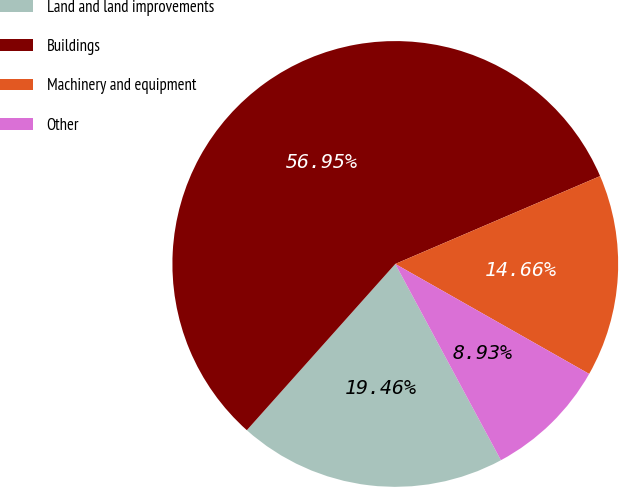<chart> <loc_0><loc_0><loc_500><loc_500><pie_chart><fcel>Land and land improvements<fcel>Buildings<fcel>Machinery and equipment<fcel>Other<nl><fcel>19.46%<fcel>56.95%<fcel>14.66%<fcel>8.93%<nl></chart> 